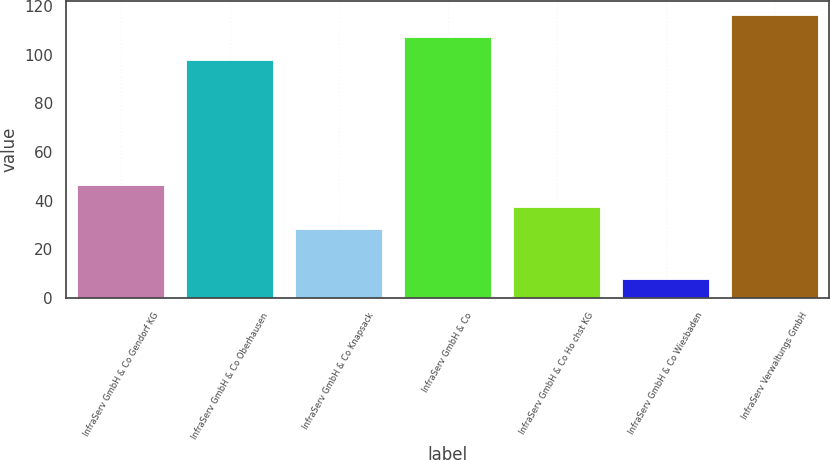Convert chart to OTSL. <chart><loc_0><loc_0><loc_500><loc_500><bar_chart><fcel>InfraServ GmbH & Co Gendorf KG<fcel>InfraServ GmbH & Co Oberhausen<fcel>InfraServ GmbH & Co Knapsack<fcel>InfraServ GmbH & Co<fcel>InfraServ GmbH & Co Ho chst KG<fcel>InfraServ GmbH & Co Wiesbaden<fcel>InfraServ Verwaltungs GmbH<nl><fcel>46.62<fcel>98<fcel>28.2<fcel>107.21<fcel>37.41<fcel>7.9<fcel>116.42<nl></chart> 